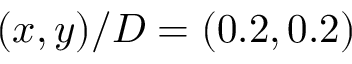<formula> <loc_0><loc_0><loc_500><loc_500>( x , y ) / D = ( 0 . 2 , 0 . 2 )</formula> 